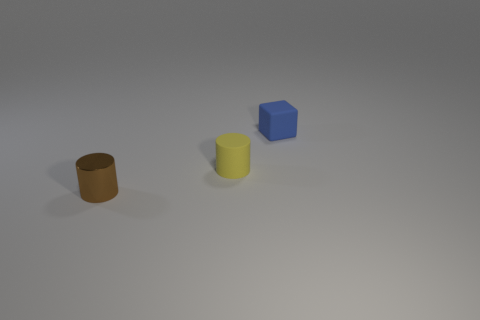Add 1 tiny blue rubber objects. How many objects exist? 4 Subtract all yellow cylinders. How many cylinders are left? 1 Subtract all cylinders. How many objects are left? 1 Subtract all gray cylinders. Subtract all purple blocks. How many cylinders are left? 2 Subtract all tiny yellow matte objects. Subtract all matte blocks. How many objects are left? 1 Add 3 blue cubes. How many blue cubes are left? 4 Add 2 rubber objects. How many rubber objects exist? 4 Subtract 1 blue cubes. How many objects are left? 2 